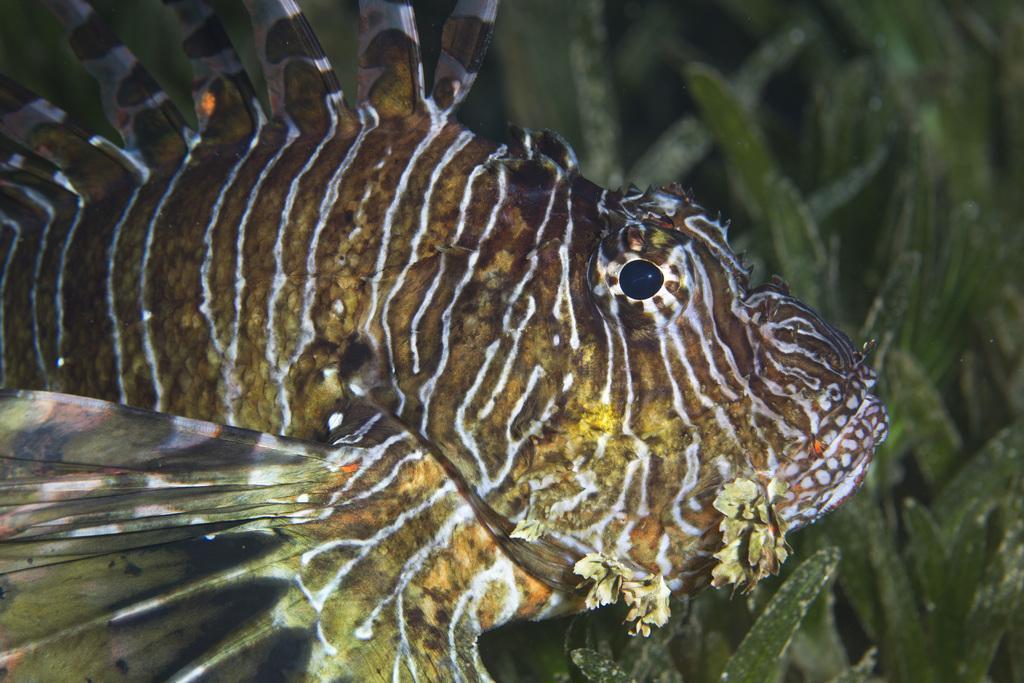Could you give a brief overview of what you see in this image? This is a water body and here we can see a fish and there are leaves. 